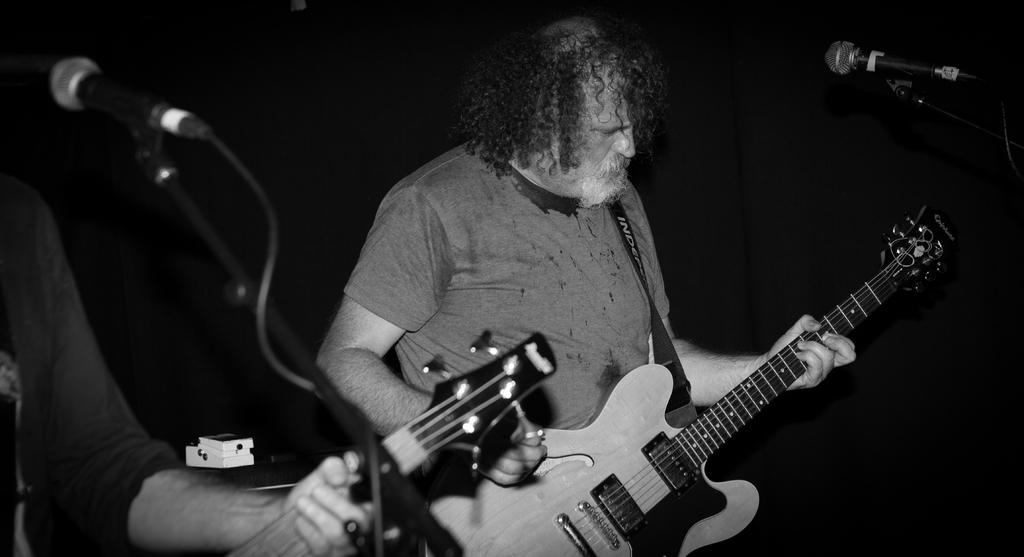Who is present in the image? There is a man in the image. What is the man doing in the image? The man is standing in the image. What object is the man holding in the image? The man is holding a guitar in the image. What other object is present in the image? There is a microphone in the image. What type of chicken is sitting on the man's shoulder in the image? There is no chicken present in the image; the man is holding a guitar and standing near a microphone. 